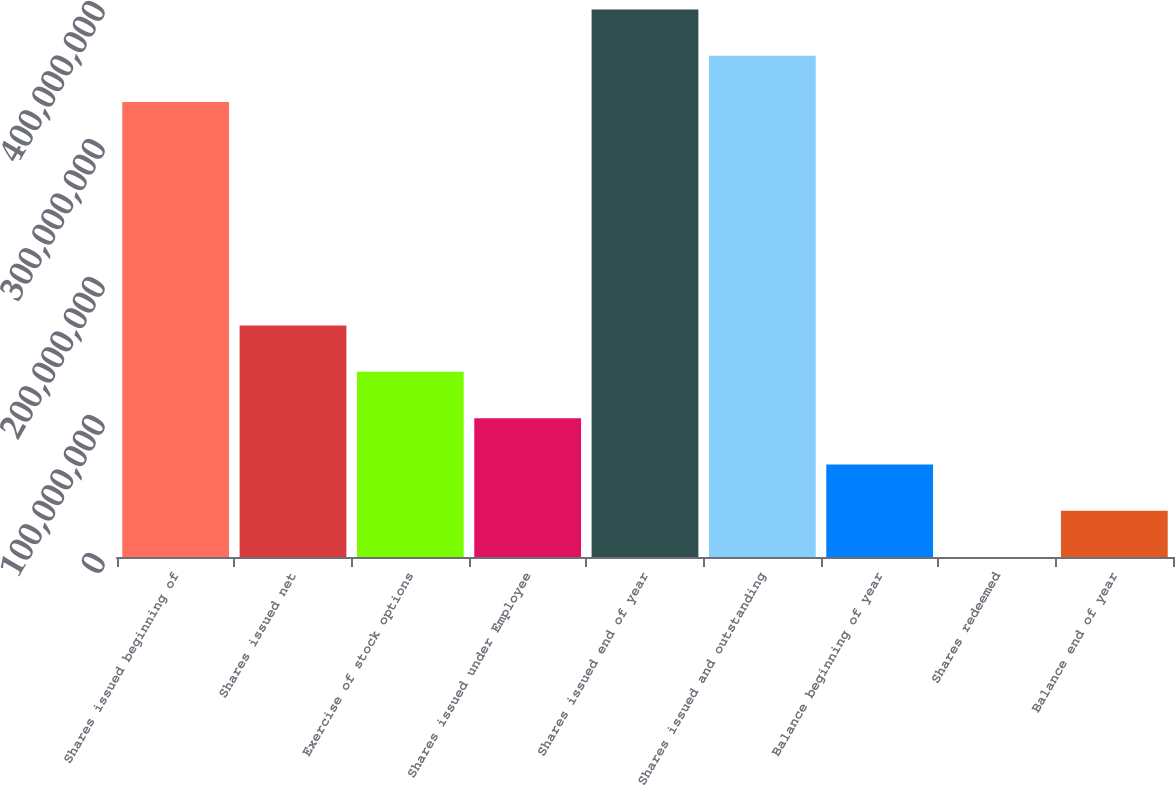Convert chart. <chart><loc_0><loc_0><loc_500><loc_500><bar_chart><fcel>Shares issued beginning of<fcel>Shares issued net<fcel>Exercise of stock options<fcel>Shares issued under Employee<fcel>Shares issued end of year<fcel>Shares issued and outstanding<fcel>Balance beginning of year<fcel>Shares redeemed<fcel>Balance end of year<nl><fcel>3.29705e+08<fcel>1.67711e+08<fcel>1.3417e+08<fcel>1.0063e+08<fcel>3.96786e+08<fcel>3.63245e+08<fcel>6.70893e+07<fcel>8250<fcel>3.35488e+07<nl></chart> 